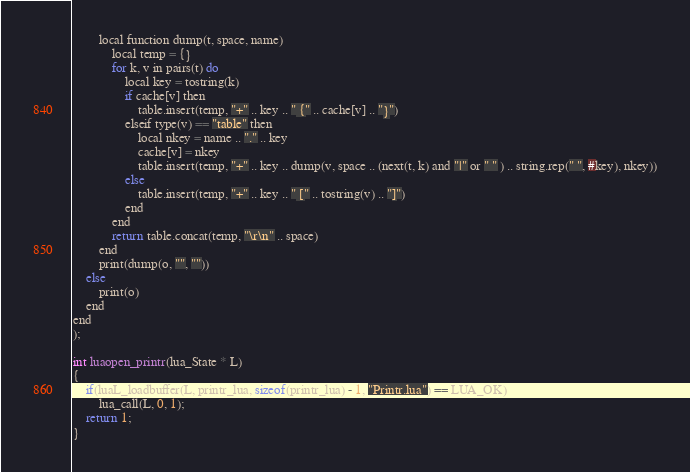Convert code to text. <code><loc_0><loc_0><loc_500><loc_500><_C_>		local function dump(t, space, name)
			local temp = {}
			for k, v in pairs(t) do
				local key = tostring(k)
				if cache[v] then
					table.insert(temp, "+" .. key .. " {" .. cache[v] .. "}")
				elseif type(v) == "table" then
					local nkey = name .. "." .. key
					cache[v] = nkey
					table.insert(temp, "+" .. key .. dump(v, space .. (next(t, k) and "|" or " " ) .. string.rep(" ", #key), nkey))
				else
					table.insert(temp, "+" .. key .. " [" .. tostring(v) .. "]")
				end
			end
			return table.concat(temp, "\r\n" .. space)
		end
		print(dump(o, "", ""))
	else
		print(o)
	end
end
);

int luaopen_printr(lua_State * L)
{
	if(luaL_loadbuffer(L, printr_lua, sizeof(printr_lua) - 1, "Printr.lua") == LUA_OK)
		lua_call(L, 0, 1);
	return 1;
}
</code> 